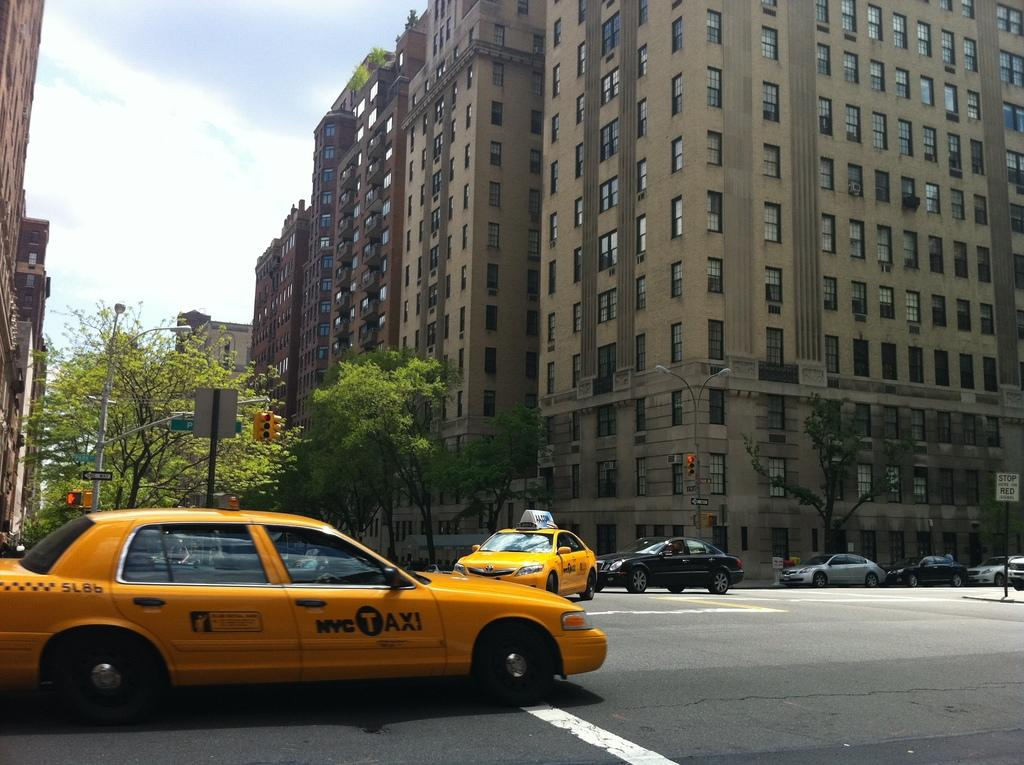<image>
Offer a succinct explanation of the picture presented. A yellow NYC Taxi sits at an intersection while traffic goes by. 